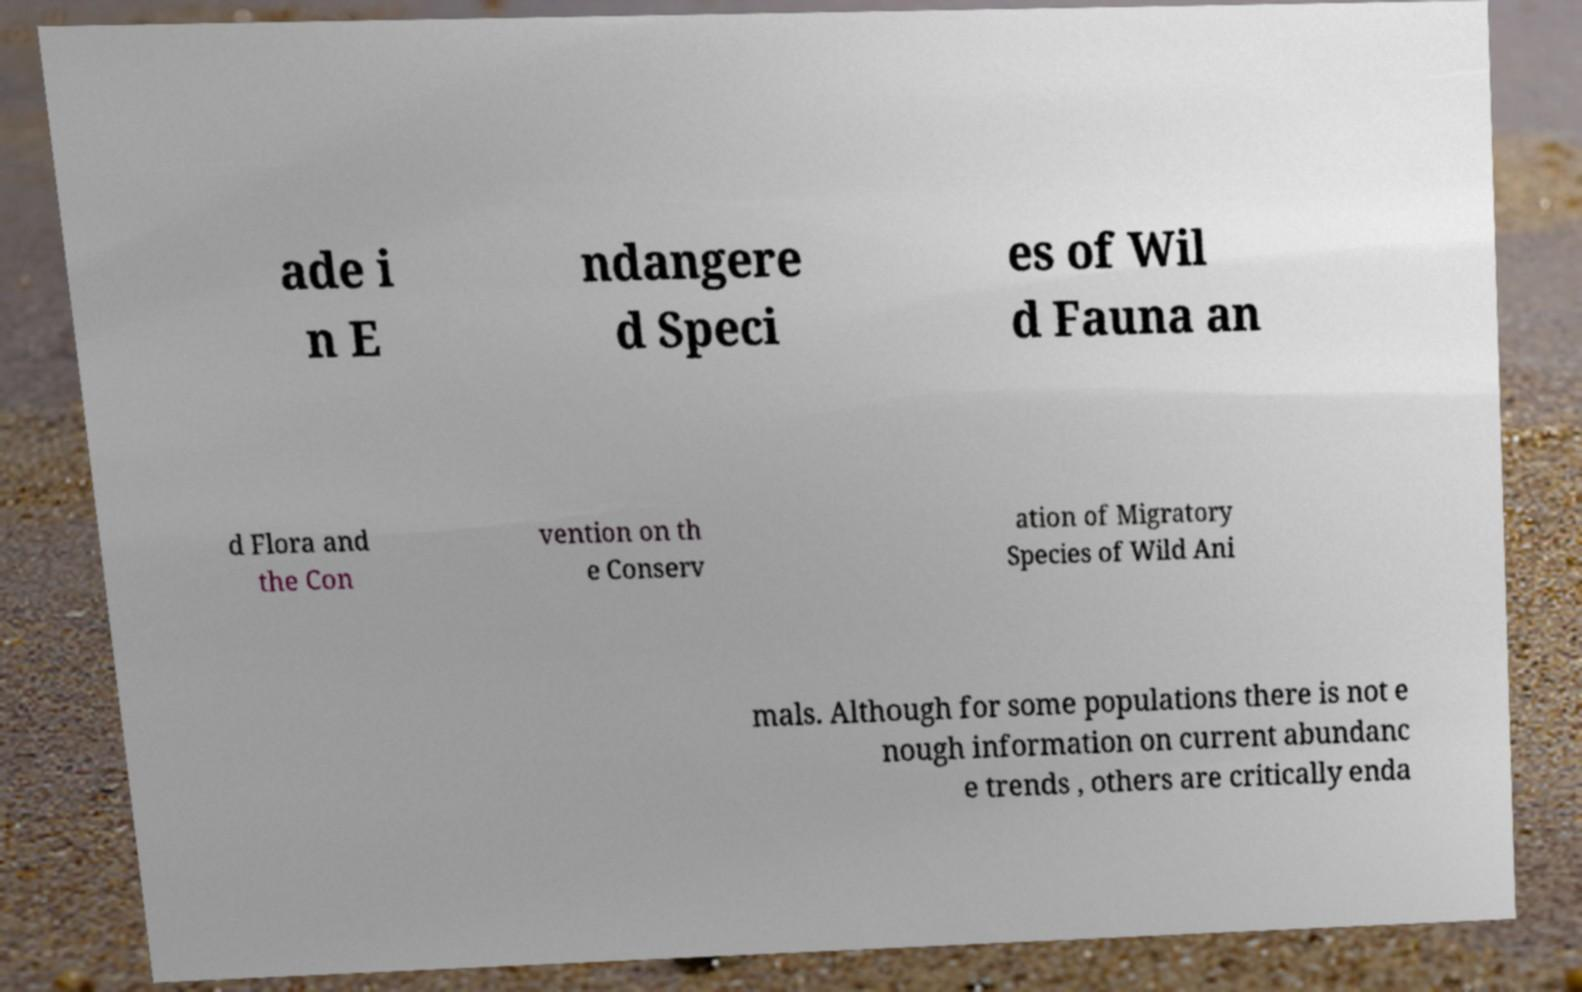Could you extract and type out the text from this image? ade i n E ndangere d Speci es of Wil d Fauna an d Flora and the Con vention on th e Conserv ation of Migratory Species of Wild Ani mals. Although for some populations there is not e nough information on current abundanc e trends , others are critically enda 